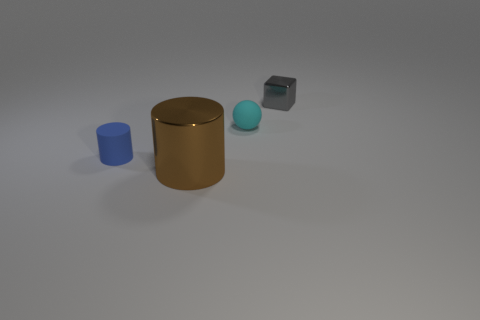The shiny object that is the same shape as the blue rubber thing is what size?
Keep it short and to the point. Large. What is the material of the thing that is on the right side of the small cylinder and on the left side of the small cyan matte thing?
Make the answer very short. Metal. Are there the same number of tiny spheres on the right side of the gray thing and big purple metal objects?
Your answer should be very brief. Yes. What number of things are things in front of the small gray block or tiny purple objects?
Provide a succinct answer. 3. There is a shiny object that is on the left side of the tiny gray block; is its color the same as the small shiny block?
Ensure brevity in your answer.  No. What is the size of the shiny thing left of the tiny metallic object?
Give a very brief answer. Large. There is a metallic object behind the small rubber thing that is left of the tiny cyan matte thing; what is its shape?
Give a very brief answer. Cube. What is the color of the other matte thing that is the same shape as the brown object?
Ensure brevity in your answer.  Blue. Is the size of the metallic object that is in front of the gray shiny cube the same as the small blue cylinder?
Keep it short and to the point. No. What number of large yellow cylinders are made of the same material as the small cube?
Your answer should be very brief. 0. 